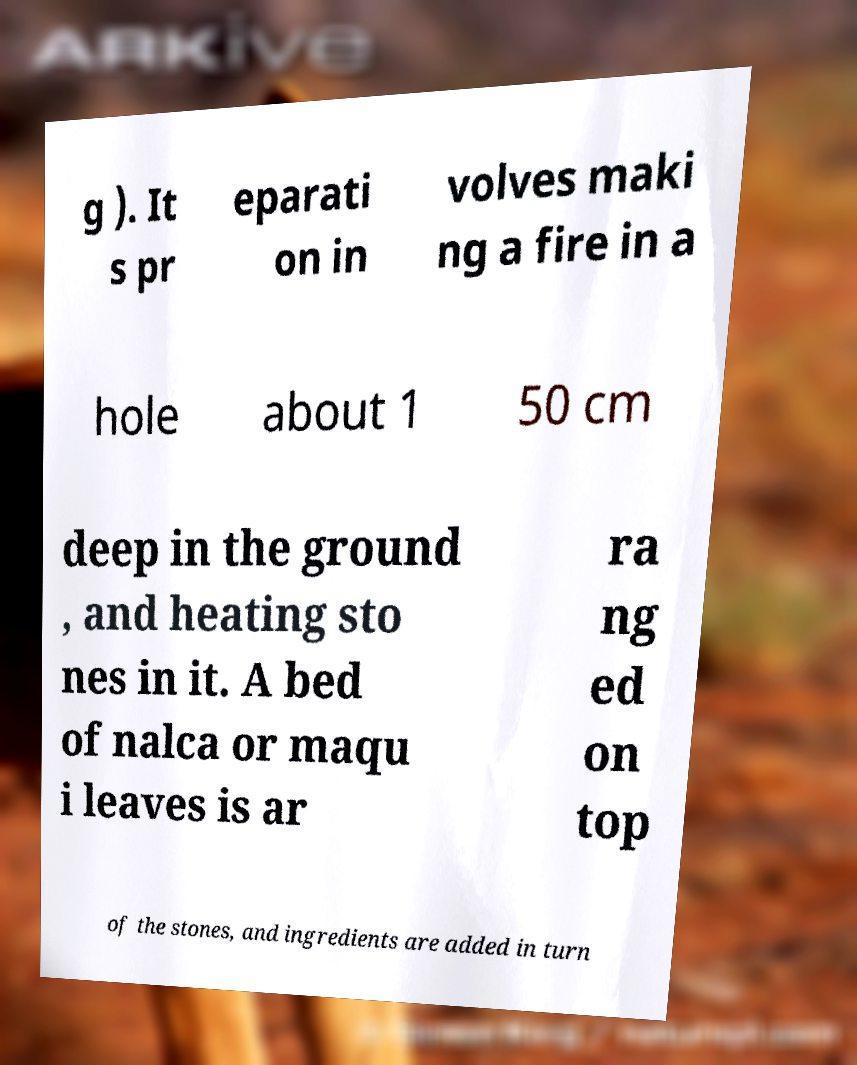For documentation purposes, I need the text within this image transcribed. Could you provide that? g ). It s pr eparati on in volves maki ng a fire in a hole about 1 50 cm deep in the ground , and heating sto nes in it. A bed of nalca or maqu i leaves is ar ra ng ed on top of the stones, and ingredients are added in turn 